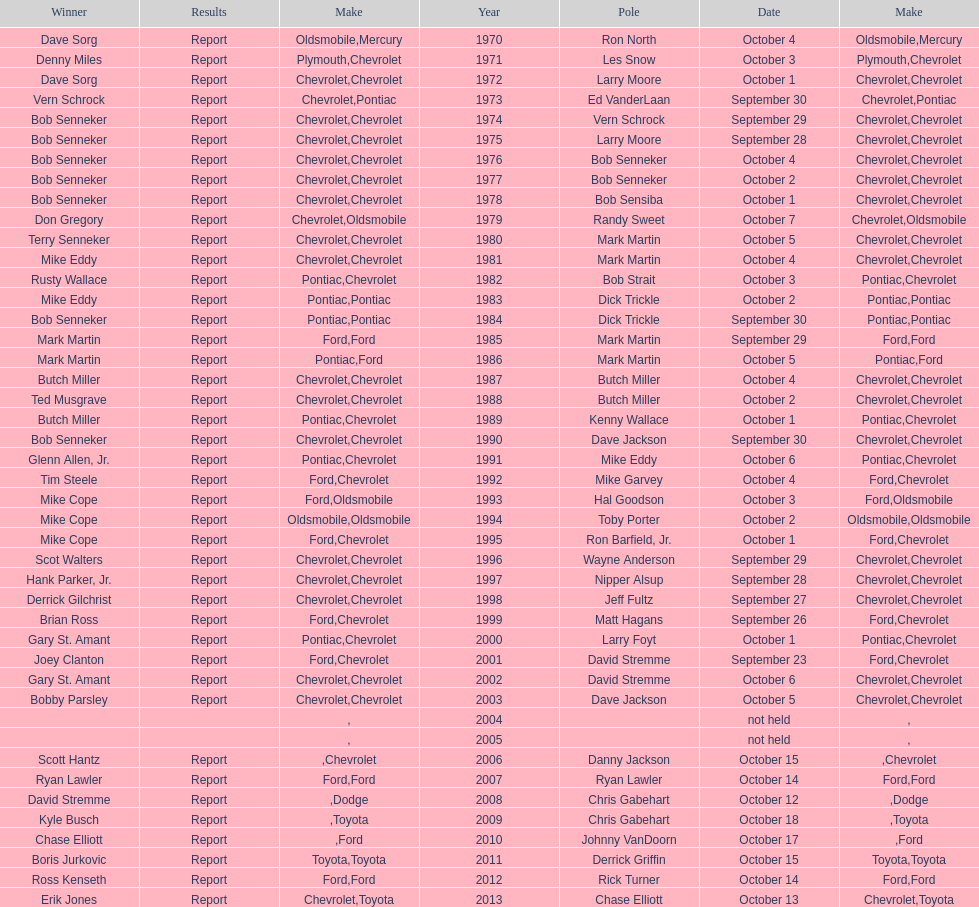Which make was used the least? Mercury. 